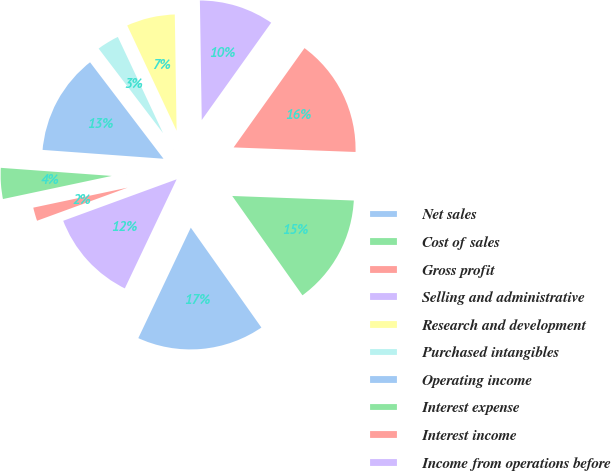Convert chart. <chart><loc_0><loc_0><loc_500><loc_500><pie_chart><fcel>Net sales<fcel>Cost of sales<fcel>Gross profit<fcel>Selling and administrative<fcel>Research and development<fcel>Purchased intangibles<fcel>Operating income<fcel>Interest expense<fcel>Interest income<fcel>Income from operations before<nl><fcel>16.85%<fcel>14.61%<fcel>15.73%<fcel>10.11%<fcel>6.74%<fcel>3.37%<fcel>13.48%<fcel>4.49%<fcel>2.25%<fcel>12.36%<nl></chart> 